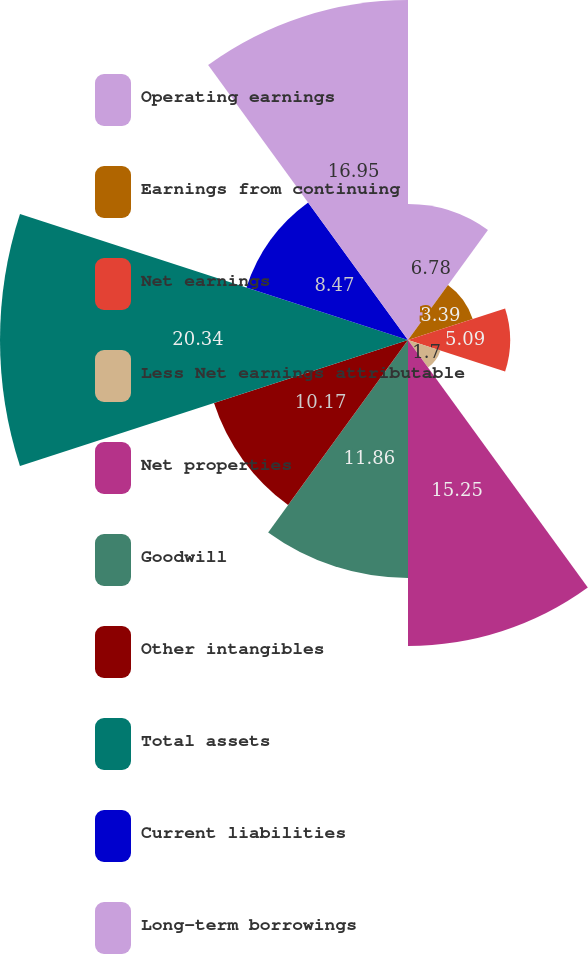Convert chart to OTSL. <chart><loc_0><loc_0><loc_500><loc_500><pie_chart><fcel>Operating earnings<fcel>Earnings from continuing<fcel>Net earnings<fcel>Less Net earnings attributable<fcel>Net properties<fcel>Goodwill<fcel>Other intangibles<fcel>Total assets<fcel>Current liabilities<fcel>Long-term borrowings<nl><fcel>6.78%<fcel>3.39%<fcel>5.09%<fcel>1.7%<fcel>15.25%<fcel>11.86%<fcel>10.17%<fcel>20.34%<fcel>8.47%<fcel>16.95%<nl></chart> 